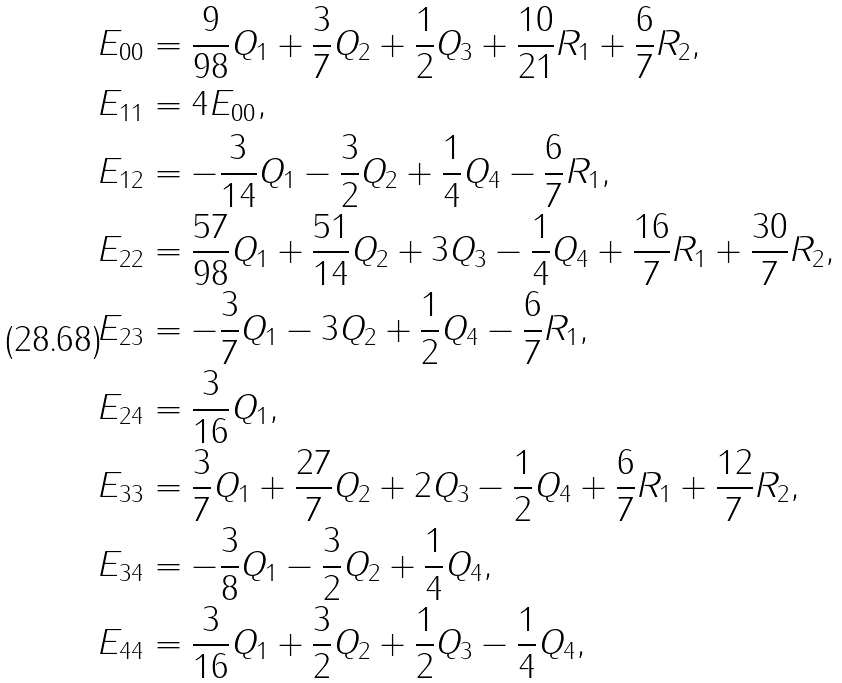Convert formula to latex. <formula><loc_0><loc_0><loc_500><loc_500>& E _ { 0 0 } = \frac { 9 } { 9 8 } Q _ { 1 } + \frac { 3 } { 7 } Q _ { 2 } + \frac { 1 } { 2 } Q _ { 3 } + \frac { 1 0 } { 2 1 } R _ { 1 } + \frac { 6 } { 7 } R _ { 2 } , \\ & E _ { 1 1 } = 4 E _ { 0 0 } , \\ & E _ { 1 2 } = - \frac { 3 } { 1 4 } Q _ { 1 } - \frac { 3 } { 2 } Q _ { 2 } + \frac { 1 } { 4 } Q _ { 4 } - \frac { 6 } { 7 } R _ { 1 } , \\ & E _ { 2 2 } = \frac { 5 7 } { 9 8 } Q _ { 1 } + \frac { 5 1 } { 1 4 } Q _ { 2 } + 3 Q _ { 3 } - \frac { 1 } { 4 } Q _ { 4 } + \frac { 1 6 } { 7 } R _ { 1 } + \frac { 3 0 } { 7 } R _ { 2 } , \\ & E _ { 2 3 } = - \frac { 3 } { 7 } Q _ { 1 } - 3 Q _ { 2 } + \frac { 1 } { 2 } Q _ { 4 } - \frac { 6 } { 7 } R _ { 1 } , \\ & E _ { 2 4 } = \frac { 3 } { 1 6 } Q _ { 1 } , \\ & E _ { 3 3 } = \frac { 3 } { 7 } Q _ { 1 } + \frac { 2 7 } { 7 } Q _ { 2 } + 2 Q _ { 3 } - \frac { 1 } { 2 } Q _ { 4 } + \frac { 6 } { 7 } R _ { 1 } + \frac { 1 2 } { 7 } R _ { 2 } , \\ & E _ { 3 4 } = - \frac { 3 } { 8 } Q _ { 1 } - \frac { 3 } { 2 } Q _ { 2 } + \frac { 1 } { 4 } Q _ { 4 } , \\ & E _ { 4 4 } = \frac { 3 } { 1 6 } Q _ { 1 } + \frac { 3 } { 2 } Q _ { 2 } + \frac { 1 } { 2 } Q _ { 3 } - \frac { 1 } { 4 } Q _ { 4 } ,</formula> 